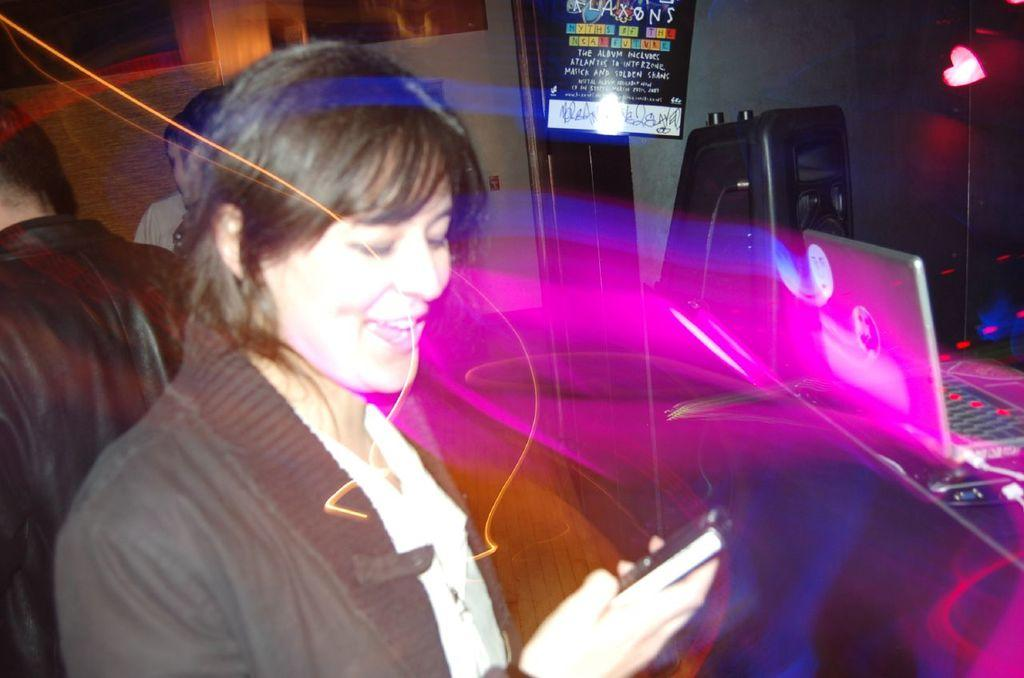Who is present in the image? There is a woman in the image. What object can be seen on the right side of the image? There is a laptop on the right side of the image. What type of linen is being used to cover the laptop in the image? There is no linen present in the image, nor is the laptop covered by any fabric. 